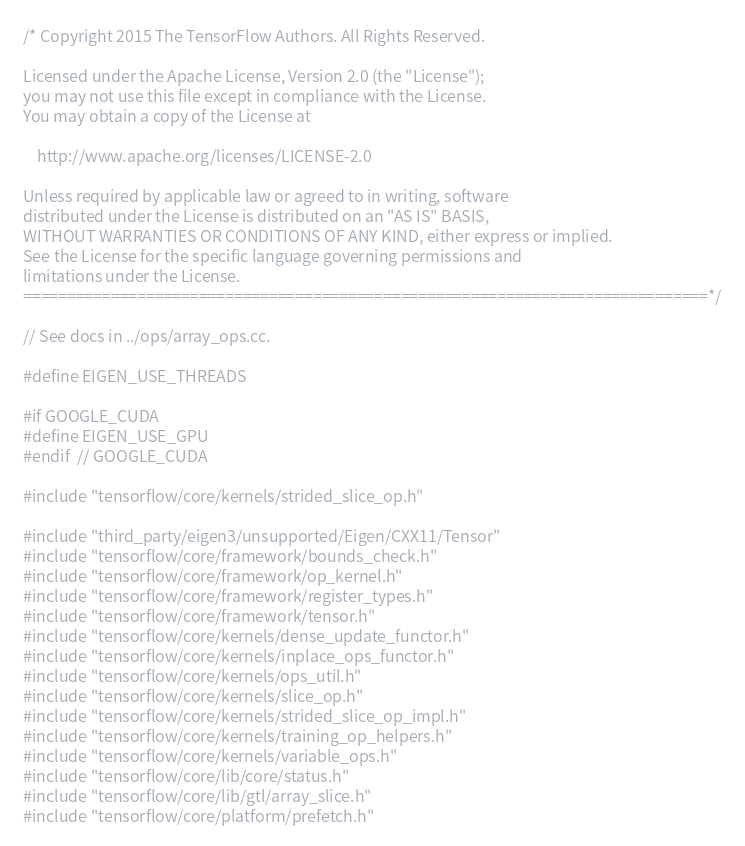<code> <loc_0><loc_0><loc_500><loc_500><_C++_>/* Copyright 2015 The TensorFlow Authors. All Rights Reserved.

Licensed under the Apache License, Version 2.0 (the "License");
you may not use this file except in compliance with the License.
You may obtain a copy of the License at

    http://www.apache.org/licenses/LICENSE-2.0

Unless required by applicable law or agreed to in writing, software
distributed under the License is distributed on an "AS IS" BASIS,
WITHOUT WARRANTIES OR CONDITIONS OF ANY KIND, either express or implied.
See the License for the specific language governing permissions and
limitations under the License.
==============================================================================*/

// See docs in ../ops/array_ops.cc.

#define EIGEN_USE_THREADS

#if GOOGLE_CUDA
#define EIGEN_USE_GPU
#endif  // GOOGLE_CUDA

#include "tensorflow/core/kernels/strided_slice_op.h"

#include "third_party/eigen3/unsupported/Eigen/CXX11/Tensor"
#include "tensorflow/core/framework/bounds_check.h"
#include "tensorflow/core/framework/op_kernel.h"
#include "tensorflow/core/framework/register_types.h"
#include "tensorflow/core/framework/tensor.h"
#include "tensorflow/core/kernels/dense_update_functor.h"
#include "tensorflow/core/kernels/inplace_ops_functor.h"
#include "tensorflow/core/kernels/ops_util.h"
#include "tensorflow/core/kernels/slice_op.h"
#include "tensorflow/core/kernels/strided_slice_op_impl.h"
#include "tensorflow/core/kernels/training_op_helpers.h"
#include "tensorflow/core/kernels/variable_ops.h"
#include "tensorflow/core/lib/core/status.h"
#include "tensorflow/core/lib/gtl/array_slice.h"
#include "tensorflow/core/platform/prefetch.h"</code> 